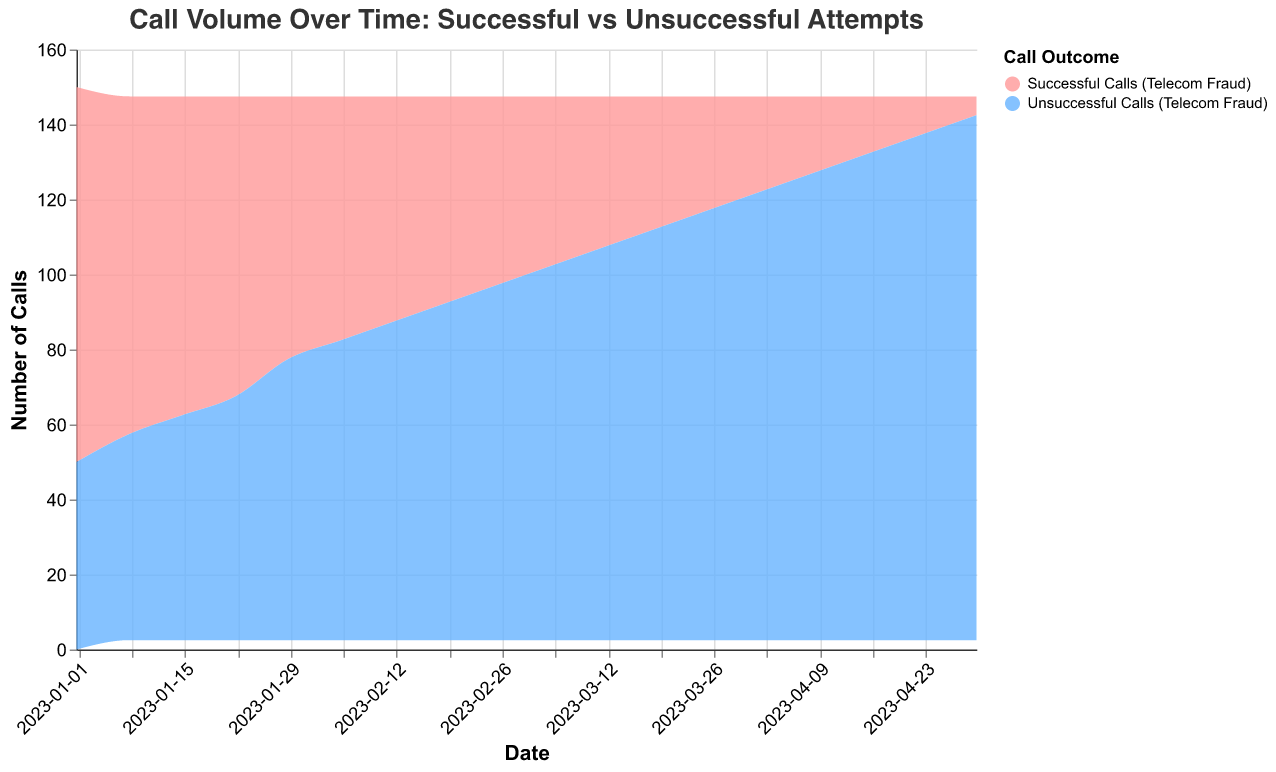What's the overall trend in the number of successful calls over time? To identify the trend in successful calls, look at the line that represents successful calls from January to April. There is a clear downward trend where the number of successful calls decreases steadily.
Answer: A decreasing trend How does the number of unsuccessful calls on January 1st compare to April 30th? Compare the values for unsuccessful calls on these two dates: January 1st has 50 unsuccessful calls and April 30th has 140 unsuccessful calls.
Answer: There are more unsuccessful calls on April 30th What is the combined total of successful and unsuccessful calls on February 5th? Add the values for successful and unsuccessful calls on February 5th: 65 (successful) + 80 (unsuccessful).
Answer: 145 When did the number of successful calls drop below 50? Review the dates and values for successful calls. It first drops below 50 on March 5th, which has 45 successful calls.
Answer: March 5th What's the difference in the number of successful calls between March 26th and April 16th? Subtract the successful calls on April 16th from those on March 26th: 30 (March 26th) - 15 (April 16th).
Answer: 15 What's the ratio of unsuccessful to successful calls on April 23rd? Divide the number of unsuccessful calls by the number of successful calls on April 23rd: 135 / 10.
Answer: 13.5 Which call type increases over the period shown, and which decreases? Evaluate the trend lines for both call types. Unsuccessful calls consistently increase, whereas successful calls consistently decrease.
Answer: Unsuccessful calls increase, successful calls decrease What's the average number of successful calls per week over the entire period? Sum the number of successful calls and divide by the number of weeks. Total successful calls: 100 + 90 + 85 + 80 + 70 + 65 + 60 + 55 + 50 + 45 + 40 + 35 + 30 + 25 + 20 + 15 + 10 + 5 = 850. There are 18 data points, so 850 / 18.
Answer: 47.22 Which month has the greatest difference between the number of successful and unsuccessful calls? Calculate the differences for each month and compare. January: 100-50, 90-55, 85-60, 80-65 & 70-75; February: 65-80, 60-85, 55-90, 50-95; March: 45-100, 40-105, 35-110, 30-115; April: 25-120, 20-125, 15-130, 10-135, 5-140. The smallest average difference is in April.
Answer: April 